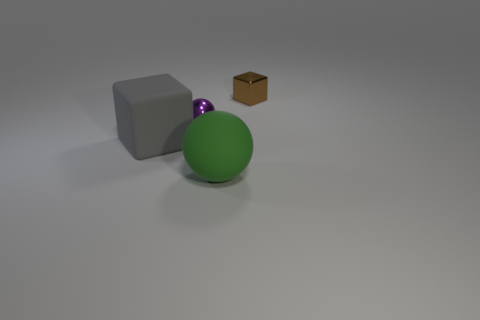Is the ball behind the matte block made of the same material as the thing that is on the left side of the tiny purple metallic ball? The green ball located behind the matte grey block is not made of the same material as the small brown cube on the left side of the tiny purple metallic ball. The green ball appears to have a smooth, possibly plastic finish, while the small brown cube on the left looks like it is made of a cardboard or a paper material with a visibly different texture and matte finish. 